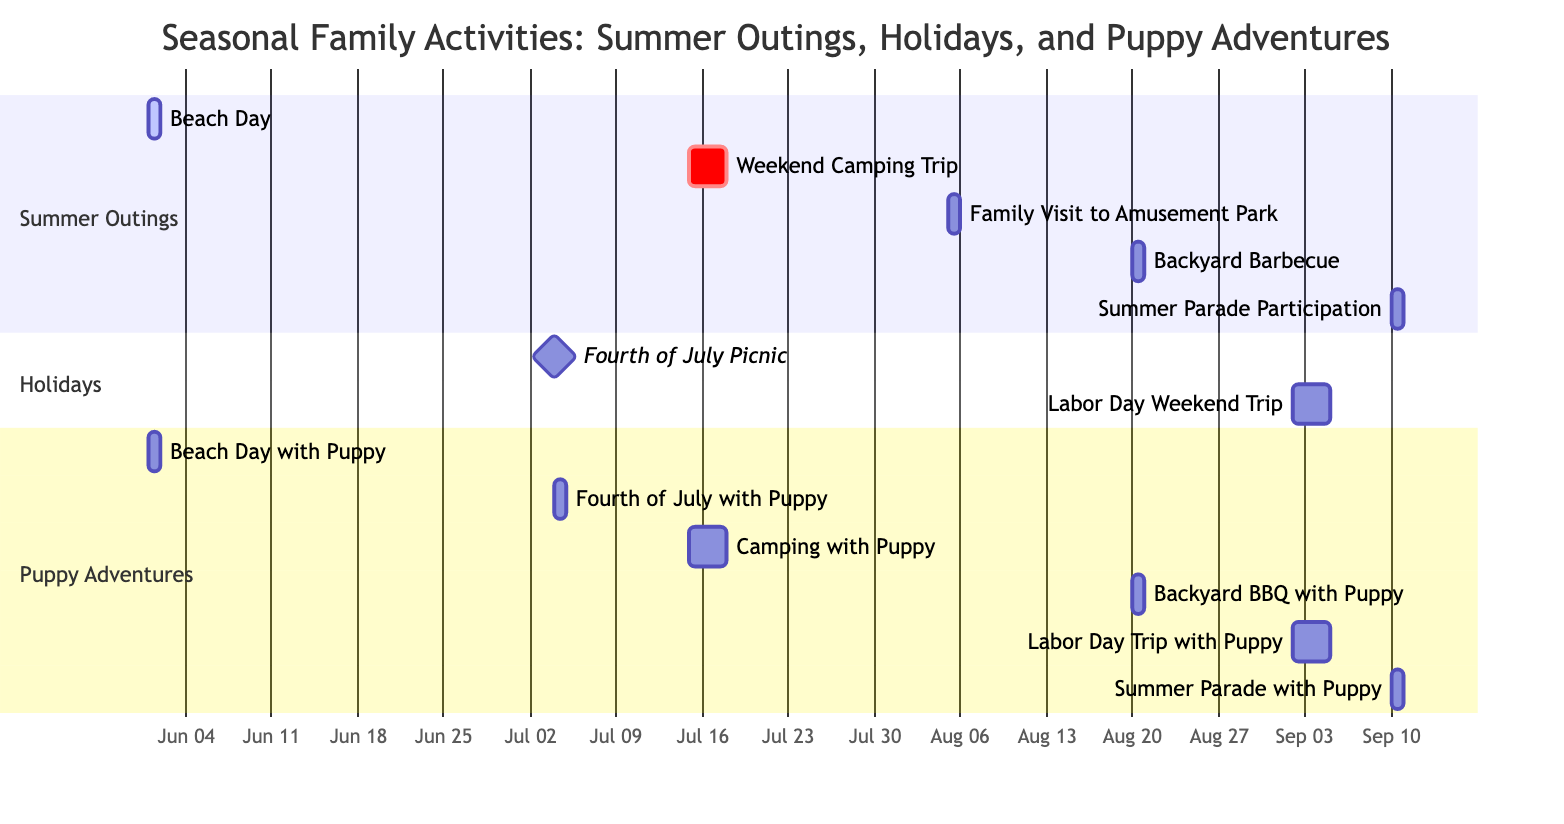What is the total number of family activities listed in the chart? The total number of activities can be counted by observing the different entries under each section (Summer Outings, Holidays, Puppy Adventures). There are 7 activities in total grouped in these sections.
Answer: 7 Which activities include the Retiree as a participant? By reviewing the participant lists under each activity, the activities that include the Retiree are Beach Day, Fourth of July Picnic, Weekend Camping Trip, Backyard Barbecue, and Labor Day Weekend Trip.
Answer: 5 What is the duration of the Weekend Camping Trip? The duration of activities can be determined by checking the start and end dates. The Weekend Camping Trip starts on July 15 and ends on July 17, which is a span of 3 days.
Answer: 3 days Which activity occurs immediately after the Fourth of July Picnic? The order of activities can be observed by looking at their start dates. The Fourth of July Picnic is on July 4, and the next activity starting chronologically is the Weekend Camping Trip, which starts on July 15.
Answer: Weekend Camping Trip How many activities are planned for a single day? Activities scheduled for one day can be identified by examining the duration indicated for each. Analyzing the chart shows that there are 4 activities marked for a single day: Beach Day, Family Visit to Amusement Park, Backyard Barbecue, and Summer Parade Participation.
Answer: 4 Which activity is classified as a milestone? In the Gantt chart, milestones are often indicated by specific notation. The Fourth of July Picnic is marked as a milestone, signifying its importance or significance in the activities schedule.
Answer: Fourth of July Picnic What are the activities that include the Puppy? To find this, look at the activities listed that have the Puppy as a participant. The activities are Beach Day, Fourth of July Picnic, Weekend Camping Trip, Backyard Barbecue, Labor Day Weekend Trip, and Summer Parade Participation.
Answer: 6 activities Which section has the most activities planned? By reviewing the numbers in each section, we can see that the Summer Outings section contains 5 activities, while the Holidays section has 2, and the Puppy Adventures section also has 6. Thus, Puppy Adventures has the most activities planned, combining the activities with the family's playful puppy.
Answer: Puppy Adventures 